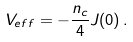Convert formula to latex. <formula><loc_0><loc_0><loc_500><loc_500>V _ { e f f } = - \frac { n _ { c } } { 4 } J ( 0 ) \, .</formula> 